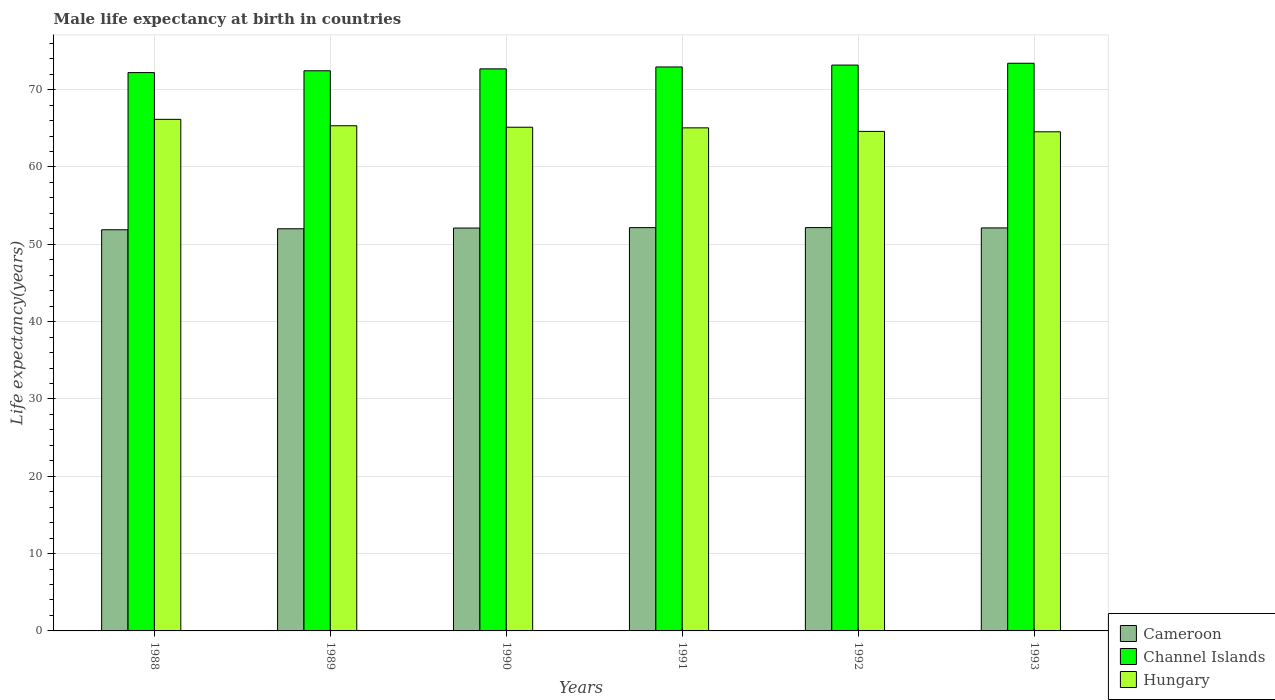How many different coloured bars are there?
Keep it short and to the point. 3. Are the number of bars per tick equal to the number of legend labels?
Provide a succinct answer. Yes. How many bars are there on the 2nd tick from the left?
Make the answer very short. 3. What is the label of the 2nd group of bars from the left?
Ensure brevity in your answer.  1989. What is the male life expectancy at birth in Hungary in 1988?
Your answer should be compact. 66.16. Across all years, what is the maximum male life expectancy at birth in Channel Islands?
Offer a terse response. 73.41. Across all years, what is the minimum male life expectancy at birth in Channel Islands?
Ensure brevity in your answer.  72.2. What is the total male life expectancy at birth in Cameroon in the graph?
Ensure brevity in your answer.  312.42. What is the difference between the male life expectancy at birth in Cameroon in 1989 and that in 1993?
Your answer should be compact. -0.11. What is the difference between the male life expectancy at birth in Channel Islands in 1992 and the male life expectancy at birth in Hungary in 1988?
Offer a terse response. 7.02. What is the average male life expectancy at birth in Cameroon per year?
Your response must be concise. 52.07. In the year 1992, what is the difference between the male life expectancy at birth in Channel Islands and male life expectancy at birth in Cameroon?
Ensure brevity in your answer.  21.02. In how many years, is the male life expectancy at birth in Channel Islands greater than 50 years?
Your answer should be compact. 6. What is the ratio of the male life expectancy at birth in Channel Islands in 1991 to that in 1992?
Provide a succinct answer. 1. Is the male life expectancy at birth in Channel Islands in 1990 less than that in 1993?
Offer a very short reply. Yes. Is the difference between the male life expectancy at birth in Channel Islands in 1989 and 1992 greater than the difference between the male life expectancy at birth in Cameroon in 1989 and 1992?
Your answer should be compact. No. What is the difference between the highest and the second highest male life expectancy at birth in Hungary?
Provide a short and direct response. 0.83. What is the difference between the highest and the lowest male life expectancy at birth in Hungary?
Provide a succinct answer. 1.61. In how many years, is the male life expectancy at birth in Hungary greater than the average male life expectancy at birth in Hungary taken over all years?
Make the answer very short. 2. What does the 2nd bar from the left in 1989 represents?
Provide a succinct answer. Channel Islands. What does the 1st bar from the right in 1993 represents?
Keep it short and to the point. Hungary. Is it the case that in every year, the sum of the male life expectancy at birth in Cameroon and male life expectancy at birth in Channel Islands is greater than the male life expectancy at birth in Hungary?
Keep it short and to the point. Yes. What is the difference between two consecutive major ticks on the Y-axis?
Provide a succinct answer. 10. Does the graph contain grids?
Offer a terse response. Yes. Where does the legend appear in the graph?
Provide a succinct answer. Bottom right. How many legend labels are there?
Make the answer very short. 3. What is the title of the graph?
Ensure brevity in your answer.  Male life expectancy at birth in countries. Does "Ecuador" appear as one of the legend labels in the graph?
Keep it short and to the point. No. What is the label or title of the X-axis?
Offer a very short reply. Years. What is the label or title of the Y-axis?
Keep it short and to the point. Life expectancy(years). What is the Life expectancy(years) of Cameroon in 1988?
Your response must be concise. 51.88. What is the Life expectancy(years) in Channel Islands in 1988?
Make the answer very short. 72.2. What is the Life expectancy(years) in Hungary in 1988?
Ensure brevity in your answer.  66.16. What is the Life expectancy(years) in Cameroon in 1989?
Offer a terse response. 52.01. What is the Life expectancy(years) of Channel Islands in 1989?
Ensure brevity in your answer.  72.44. What is the Life expectancy(years) of Hungary in 1989?
Your answer should be compact. 65.33. What is the Life expectancy(years) of Cameroon in 1990?
Offer a terse response. 52.1. What is the Life expectancy(years) of Channel Islands in 1990?
Keep it short and to the point. 72.69. What is the Life expectancy(years) in Hungary in 1990?
Provide a succinct answer. 65.14. What is the Life expectancy(years) of Cameroon in 1991?
Your answer should be very brief. 52.16. What is the Life expectancy(years) of Channel Islands in 1991?
Your response must be concise. 72.93. What is the Life expectancy(years) in Hungary in 1991?
Provide a succinct answer. 65.06. What is the Life expectancy(years) in Cameroon in 1992?
Provide a succinct answer. 52.16. What is the Life expectancy(years) in Channel Islands in 1992?
Keep it short and to the point. 73.18. What is the Life expectancy(years) in Hungary in 1992?
Your answer should be compact. 64.6. What is the Life expectancy(years) in Cameroon in 1993?
Offer a very short reply. 52.12. What is the Life expectancy(years) of Channel Islands in 1993?
Your response must be concise. 73.41. What is the Life expectancy(years) of Hungary in 1993?
Your answer should be very brief. 64.55. Across all years, what is the maximum Life expectancy(years) of Cameroon?
Your answer should be very brief. 52.16. Across all years, what is the maximum Life expectancy(years) in Channel Islands?
Provide a succinct answer. 73.41. Across all years, what is the maximum Life expectancy(years) of Hungary?
Ensure brevity in your answer.  66.16. Across all years, what is the minimum Life expectancy(years) in Cameroon?
Give a very brief answer. 51.88. Across all years, what is the minimum Life expectancy(years) in Channel Islands?
Provide a short and direct response. 72.2. Across all years, what is the minimum Life expectancy(years) of Hungary?
Offer a terse response. 64.55. What is the total Life expectancy(years) in Cameroon in the graph?
Offer a terse response. 312.42. What is the total Life expectancy(years) of Channel Islands in the graph?
Ensure brevity in your answer.  436.86. What is the total Life expectancy(years) of Hungary in the graph?
Offer a very short reply. 390.84. What is the difference between the Life expectancy(years) of Cameroon in 1988 and that in 1989?
Ensure brevity in your answer.  -0.13. What is the difference between the Life expectancy(years) of Channel Islands in 1988 and that in 1989?
Offer a very short reply. -0.24. What is the difference between the Life expectancy(years) in Hungary in 1988 and that in 1989?
Provide a succinct answer. 0.83. What is the difference between the Life expectancy(years) in Cameroon in 1988 and that in 1990?
Keep it short and to the point. -0.22. What is the difference between the Life expectancy(years) in Channel Islands in 1988 and that in 1990?
Keep it short and to the point. -0.48. What is the difference between the Life expectancy(years) of Hungary in 1988 and that in 1990?
Provide a short and direct response. 1.02. What is the difference between the Life expectancy(years) of Cameroon in 1988 and that in 1991?
Keep it short and to the point. -0.27. What is the difference between the Life expectancy(years) in Channel Islands in 1988 and that in 1991?
Ensure brevity in your answer.  -0.73. What is the difference between the Life expectancy(years) in Hungary in 1988 and that in 1991?
Offer a very short reply. 1.1. What is the difference between the Life expectancy(years) in Cameroon in 1988 and that in 1992?
Keep it short and to the point. -0.28. What is the difference between the Life expectancy(years) of Channel Islands in 1988 and that in 1992?
Give a very brief answer. -0.97. What is the difference between the Life expectancy(years) of Hungary in 1988 and that in 1992?
Keep it short and to the point. 1.56. What is the difference between the Life expectancy(years) in Cameroon in 1988 and that in 1993?
Provide a succinct answer. -0.24. What is the difference between the Life expectancy(years) of Channel Islands in 1988 and that in 1993?
Provide a succinct answer. -1.21. What is the difference between the Life expectancy(years) of Hungary in 1988 and that in 1993?
Provide a short and direct response. 1.61. What is the difference between the Life expectancy(years) in Cameroon in 1989 and that in 1990?
Your answer should be very brief. -0.09. What is the difference between the Life expectancy(years) of Channel Islands in 1989 and that in 1990?
Offer a very short reply. -0.25. What is the difference between the Life expectancy(years) in Hungary in 1989 and that in 1990?
Your response must be concise. 0.19. What is the difference between the Life expectancy(years) of Cameroon in 1989 and that in 1991?
Provide a short and direct response. -0.15. What is the difference between the Life expectancy(years) in Channel Islands in 1989 and that in 1991?
Keep it short and to the point. -0.49. What is the difference between the Life expectancy(years) of Hungary in 1989 and that in 1991?
Your response must be concise. 0.27. What is the difference between the Life expectancy(years) of Cameroon in 1989 and that in 1992?
Make the answer very short. -0.15. What is the difference between the Life expectancy(years) in Channel Islands in 1989 and that in 1992?
Your response must be concise. -0.73. What is the difference between the Life expectancy(years) of Hungary in 1989 and that in 1992?
Your answer should be very brief. 0.73. What is the difference between the Life expectancy(years) in Cameroon in 1989 and that in 1993?
Give a very brief answer. -0.11. What is the difference between the Life expectancy(years) of Channel Islands in 1989 and that in 1993?
Your response must be concise. -0.97. What is the difference between the Life expectancy(years) in Hungary in 1989 and that in 1993?
Offer a very short reply. 0.78. What is the difference between the Life expectancy(years) in Cameroon in 1990 and that in 1991?
Give a very brief answer. -0.05. What is the difference between the Life expectancy(years) of Channel Islands in 1990 and that in 1991?
Offer a very short reply. -0.25. What is the difference between the Life expectancy(years) of Cameroon in 1990 and that in 1992?
Offer a terse response. -0.06. What is the difference between the Life expectancy(years) of Channel Islands in 1990 and that in 1992?
Ensure brevity in your answer.  -0.49. What is the difference between the Life expectancy(years) in Hungary in 1990 and that in 1992?
Ensure brevity in your answer.  0.54. What is the difference between the Life expectancy(years) of Cameroon in 1990 and that in 1993?
Offer a very short reply. -0.02. What is the difference between the Life expectancy(years) in Channel Islands in 1990 and that in 1993?
Give a very brief answer. -0.72. What is the difference between the Life expectancy(years) in Hungary in 1990 and that in 1993?
Provide a succinct answer. 0.59. What is the difference between the Life expectancy(years) in Cameroon in 1991 and that in 1992?
Your answer should be very brief. -0.01. What is the difference between the Life expectancy(years) of Channel Islands in 1991 and that in 1992?
Offer a very short reply. -0.24. What is the difference between the Life expectancy(years) in Hungary in 1991 and that in 1992?
Your answer should be very brief. 0.46. What is the difference between the Life expectancy(years) of Cameroon in 1991 and that in 1993?
Offer a very short reply. 0.04. What is the difference between the Life expectancy(years) of Channel Islands in 1991 and that in 1993?
Make the answer very short. -0.48. What is the difference between the Life expectancy(years) of Hungary in 1991 and that in 1993?
Your response must be concise. 0.51. What is the difference between the Life expectancy(years) in Cameroon in 1992 and that in 1993?
Your answer should be very brief. 0.04. What is the difference between the Life expectancy(years) of Channel Islands in 1992 and that in 1993?
Provide a short and direct response. -0.24. What is the difference between the Life expectancy(years) in Cameroon in 1988 and the Life expectancy(years) in Channel Islands in 1989?
Keep it short and to the point. -20.56. What is the difference between the Life expectancy(years) of Cameroon in 1988 and the Life expectancy(years) of Hungary in 1989?
Provide a succinct answer. -13.45. What is the difference between the Life expectancy(years) in Channel Islands in 1988 and the Life expectancy(years) in Hungary in 1989?
Your response must be concise. 6.87. What is the difference between the Life expectancy(years) in Cameroon in 1988 and the Life expectancy(years) in Channel Islands in 1990?
Provide a short and direct response. -20.81. What is the difference between the Life expectancy(years) of Cameroon in 1988 and the Life expectancy(years) of Hungary in 1990?
Keep it short and to the point. -13.26. What is the difference between the Life expectancy(years) in Channel Islands in 1988 and the Life expectancy(years) in Hungary in 1990?
Ensure brevity in your answer.  7.06. What is the difference between the Life expectancy(years) in Cameroon in 1988 and the Life expectancy(years) in Channel Islands in 1991?
Provide a short and direct response. -21.05. What is the difference between the Life expectancy(years) of Cameroon in 1988 and the Life expectancy(years) of Hungary in 1991?
Your answer should be compact. -13.18. What is the difference between the Life expectancy(years) of Channel Islands in 1988 and the Life expectancy(years) of Hungary in 1991?
Offer a terse response. 7.14. What is the difference between the Life expectancy(years) of Cameroon in 1988 and the Life expectancy(years) of Channel Islands in 1992?
Give a very brief answer. -21.3. What is the difference between the Life expectancy(years) in Cameroon in 1988 and the Life expectancy(years) in Hungary in 1992?
Your answer should be very brief. -12.72. What is the difference between the Life expectancy(years) of Channel Islands in 1988 and the Life expectancy(years) of Hungary in 1992?
Your answer should be compact. 7.6. What is the difference between the Life expectancy(years) of Cameroon in 1988 and the Life expectancy(years) of Channel Islands in 1993?
Your response must be concise. -21.53. What is the difference between the Life expectancy(years) in Cameroon in 1988 and the Life expectancy(years) in Hungary in 1993?
Your response must be concise. -12.67. What is the difference between the Life expectancy(years) in Channel Islands in 1988 and the Life expectancy(years) in Hungary in 1993?
Provide a succinct answer. 7.65. What is the difference between the Life expectancy(years) in Cameroon in 1989 and the Life expectancy(years) in Channel Islands in 1990?
Provide a succinct answer. -20.68. What is the difference between the Life expectancy(years) in Cameroon in 1989 and the Life expectancy(years) in Hungary in 1990?
Give a very brief answer. -13.13. What is the difference between the Life expectancy(years) of Channel Islands in 1989 and the Life expectancy(years) of Hungary in 1990?
Your answer should be very brief. 7.3. What is the difference between the Life expectancy(years) in Cameroon in 1989 and the Life expectancy(years) in Channel Islands in 1991?
Your answer should be compact. -20.93. What is the difference between the Life expectancy(years) in Cameroon in 1989 and the Life expectancy(years) in Hungary in 1991?
Give a very brief answer. -13.05. What is the difference between the Life expectancy(years) in Channel Islands in 1989 and the Life expectancy(years) in Hungary in 1991?
Provide a short and direct response. 7.38. What is the difference between the Life expectancy(years) in Cameroon in 1989 and the Life expectancy(years) in Channel Islands in 1992?
Offer a very short reply. -21.17. What is the difference between the Life expectancy(years) in Cameroon in 1989 and the Life expectancy(years) in Hungary in 1992?
Ensure brevity in your answer.  -12.59. What is the difference between the Life expectancy(years) of Channel Islands in 1989 and the Life expectancy(years) of Hungary in 1992?
Keep it short and to the point. 7.84. What is the difference between the Life expectancy(years) in Cameroon in 1989 and the Life expectancy(years) in Channel Islands in 1993?
Your response must be concise. -21.41. What is the difference between the Life expectancy(years) of Cameroon in 1989 and the Life expectancy(years) of Hungary in 1993?
Provide a succinct answer. -12.54. What is the difference between the Life expectancy(years) in Channel Islands in 1989 and the Life expectancy(years) in Hungary in 1993?
Make the answer very short. 7.89. What is the difference between the Life expectancy(years) of Cameroon in 1990 and the Life expectancy(years) of Channel Islands in 1991?
Keep it short and to the point. -20.83. What is the difference between the Life expectancy(years) of Cameroon in 1990 and the Life expectancy(years) of Hungary in 1991?
Provide a short and direct response. -12.96. What is the difference between the Life expectancy(years) in Channel Islands in 1990 and the Life expectancy(years) in Hungary in 1991?
Give a very brief answer. 7.63. What is the difference between the Life expectancy(years) of Cameroon in 1990 and the Life expectancy(years) of Channel Islands in 1992?
Provide a short and direct response. -21.07. What is the difference between the Life expectancy(years) of Cameroon in 1990 and the Life expectancy(years) of Hungary in 1992?
Make the answer very short. -12.5. What is the difference between the Life expectancy(years) of Channel Islands in 1990 and the Life expectancy(years) of Hungary in 1992?
Your response must be concise. 8.09. What is the difference between the Life expectancy(years) in Cameroon in 1990 and the Life expectancy(years) in Channel Islands in 1993?
Ensure brevity in your answer.  -21.31. What is the difference between the Life expectancy(years) in Cameroon in 1990 and the Life expectancy(years) in Hungary in 1993?
Your answer should be compact. -12.45. What is the difference between the Life expectancy(years) in Channel Islands in 1990 and the Life expectancy(years) in Hungary in 1993?
Make the answer very short. 8.14. What is the difference between the Life expectancy(years) in Cameroon in 1991 and the Life expectancy(years) in Channel Islands in 1992?
Keep it short and to the point. -21.02. What is the difference between the Life expectancy(years) in Cameroon in 1991 and the Life expectancy(years) in Hungary in 1992?
Your answer should be very brief. -12.45. What is the difference between the Life expectancy(years) of Channel Islands in 1991 and the Life expectancy(years) of Hungary in 1992?
Your answer should be very brief. 8.33. What is the difference between the Life expectancy(years) in Cameroon in 1991 and the Life expectancy(years) in Channel Islands in 1993?
Provide a succinct answer. -21.26. What is the difference between the Life expectancy(years) in Cameroon in 1991 and the Life expectancy(years) in Hungary in 1993?
Keep it short and to the point. -12.39. What is the difference between the Life expectancy(years) of Channel Islands in 1991 and the Life expectancy(years) of Hungary in 1993?
Provide a succinct answer. 8.38. What is the difference between the Life expectancy(years) in Cameroon in 1992 and the Life expectancy(years) in Channel Islands in 1993?
Provide a succinct answer. -21.25. What is the difference between the Life expectancy(years) of Cameroon in 1992 and the Life expectancy(years) of Hungary in 1993?
Offer a very short reply. -12.39. What is the difference between the Life expectancy(years) of Channel Islands in 1992 and the Life expectancy(years) of Hungary in 1993?
Offer a terse response. 8.63. What is the average Life expectancy(years) of Cameroon per year?
Keep it short and to the point. 52.07. What is the average Life expectancy(years) of Channel Islands per year?
Provide a short and direct response. 72.81. What is the average Life expectancy(years) in Hungary per year?
Offer a very short reply. 65.14. In the year 1988, what is the difference between the Life expectancy(years) of Cameroon and Life expectancy(years) of Channel Islands?
Offer a very short reply. -20.32. In the year 1988, what is the difference between the Life expectancy(years) of Cameroon and Life expectancy(years) of Hungary?
Provide a short and direct response. -14.28. In the year 1988, what is the difference between the Life expectancy(years) of Channel Islands and Life expectancy(years) of Hungary?
Offer a terse response. 6.04. In the year 1989, what is the difference between the Life expectancy(years) of Cameroon and Life expectancy(years) of Channel Islands?
Make the answer very short. -20.43. In the year 1989, what is the difference between the Life expectancy(years) in Cameroon and Life expectancy(years) in Hungary?
Make the answer very short. -13.32. In the year 1989, what is the difference between the Life expectancy(years) in Channel Islands and Life expectancy(years) in Hungary?
Your response must be concise. 7.11. In the year 1990, what is the difference between the Life expectancy(years) in Cameroon and Life expectancy(years) in Channel Islands?
Make the answer very short. -20.59. In the year 1990, what is the difference between the Life expectancy(years) in Cameroon and Life expectancy(years) in Hungary?
Provide a succinct answer. -13.04. In the year 1990, what is the difference between the Life expectancy(years) of Channel Islands and Life expectancy(years) of Hungary?
Offer a very short reply. 7.55. In the year 1991, what is the difference between the Life expectancy(years) in Cameroon and Life expectancy(years) in Channel Islands?
Your answer should be very brief. -20.78. In the year 1991, what is the difference between the Life expectancy(years) of Cameroon and Life expectancy(years) of Hungary?
Your answer should be compact. -12.9. In the year 1991, what is the difference between the Life expectancy(years) of Channel Islands and Life expectancy(years) of Hungary?
Make the answer very short. 7.87. In the year 1992, what is the difference between the Life expectancy(years) of Cameroon and Life expectancy(years) of Channel Islands?
Your response must be concise. -21.02. In the year 1992, what is the difference between the Life expectancy(years) of Cameroon and Life expectancy(years) of Hungary?
Offer a very short reply. -12.44. In the year 1992, what is the difference between the Life expectancy(years) of Channel Islands and Life expectancy(years) of Hungary?
Keep it short and to the point. 8.58. In the year 1993, what is the difference between the Life expectancy(years) of Cameroon and Life expectancy(years) of Channel Islands?
Make the answer very short. -21.3. In the year 1993, what is the difference between the Life expectancy(years) in Cameroon and Life expectancy(years) in Hungary?
Make the answer very short. -12.43. In the year 1993, what is the difference between the Life expectancy(years) in Channel Islands and Life expectancy(years) in Hungary?
Keep it short and to the point. 8.86. What is the ratio of the Life expectancy(years) of Cameroon in 1988 to that in 1989?
Provide a succinct answer. 1. What is the ratio of the Life expectancy(years) in Channel Islands in 1988 to that in 1989?
Offer a very short reply. 1. What is the ratio of the Life expectancy(years) of Hungary in 1988 to that in 1989?
Keep it short and to the point. 1.01. What is the ratio of the Life expectancy(years) of Hungary in 1988 to that in 1990?
Ensure brevity in your answer.  1.02. What is the ratio of the Life expectancy(years) of Channel Islands in 1988 to that in 1991?
Make the answer very short. 0.99. What is the ratio of the Life expectancy(years) of Hungary in 1988 to that in 1991?
Keep it short and to the point. 1.02. What is the ratio of the Life expectancy(years) of Cameroon in 1988 to that in 1992?
Make the answer very short. 0.99. What is the ratio of the Life expectancy(years) of Channel Islands in 1988 to that in 1992?
Your response must be concise. 0.99. What is the ratio of the Life expectancy(years) of Hungary in 1988 to that in 1992?
Give a very brief answer. 1.02. What is the ratio of the Life expectancy(years) of Channel Islands in 1988 to that in 1993?
Offer a terse response. 0.98. What is the ratio of the Life expectancy(years) of Hungary in 1988 to that in 1993?
Ensure brevity in your answer.  1.02. What is the ratio of the Life expectancy(years) in Cameroon in 1989 to that in 1990?
Provide a succinct answer. 1. What is the ratio of the Life expectancy(years) of Channel Islands in 1989 to that in 1991?
Your answer should be compact. 0.99. What is the ratio of the Life expectancy(years) of Hungary in 1989 to that in 1991?
Keep it short and to the point. 1. What is the ratio of the Life expectancy(years) in Channel Islands in 1989 to that in 1992?
Offer a very short reply. 0.99. What is the ratio of the Life expectancy(years) of Hungary in 1989 to that in 1992?
Offer a terse response. 1.01. What is the ratio of the Life expectancy(years) of Hungary in 1989 to that in 1993?
Your answer should be very brief. 1.01. What is the ratio of the Life expectancy(years) in Cameroon in 1990 to that in 1991?
Give a very brief answer. 1. What is the ratio of the Life expectancy(years) of Channel Islands in 1990 to that in 1991?
Your answer should be very brief. 1. What is the ratio of the Life expectancy(years) in Hungary in 1990 to that in 1992?
Offer a terse response. 1.01. What is the ratio of the Life expectancy(years) of Cameroon in 1990 to that in 1993?
Offer a very short reply. 1. What is the ratio of the Life expectancy(years) in Channel Islands in 1990 to that in 1993?
Give a very brief answer. 0.99. What is the ratio of the Life expectancy(years) of Hungary in 1990 to that in 1993?
Provide a succinct answer. 1.01. What is the ratio of the Life expectancy(years) of Channel Islands in 1991 to that in 1992?
Give a very brief answer. 1. What is the ratio of the Life expectancy(years) in Hungary in 1991 to that in 1992?
Keep it short and to the point. 1.01. What is the ratio of the Life expectancy(years) in Cameroon in 1991 to that in 1993?
Provide a succinct answer. 1. What is the ratio of the Life expectancy(years) in Hungary in 1991 to that in 1993?
Provide a short and direct response. 1.01. What is the ratio of the Life expectancy(years) in Channel Islands in 1992 to that in 1993?
Your answer should be very brief. 1. What is the difference between the highest and the second highest Life expectancy(years) in Cameroon?
Provide a short and direct response. 0.01. What is the difference between the highest and the second highest Life expectancy(years) of Channel Islands?
Your answer should be very brief. 0.24. What is the difference between the highest and the second highest Life expectancy(years) of Hungary?
Your answer should be compact. 0.83. What is the difference between the highest and the lowest Life expectancy(years) of Cameroon?
Your answer should be very brief. 0.28. What is the difference between the highest and the lowest Life expectancy(years) of Channel Islands?
Provide a succinct answer. 1.21. What is the difference between the highest and the lowest Life expectancy(years) of Hungary?
Offer a terse response. 1.61. 